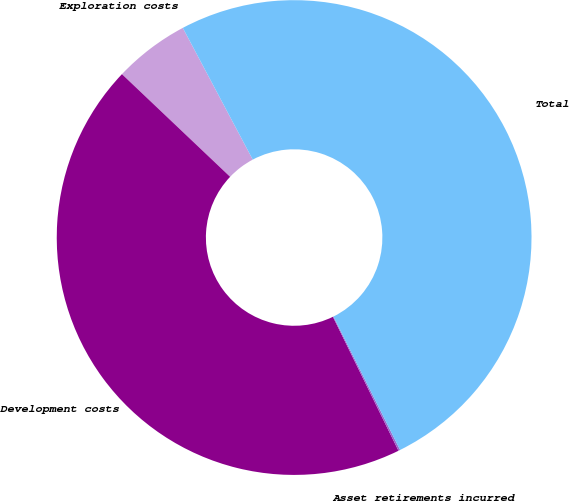<chart> <loc_0><loc_0><loc_500><loc_500><pie_chart><fcel>Exploration costs<fcel>Development costs<fcel>Asset retirements incurred<fcel>Total<nl><fcel>5.15%<fcel>44.33%<fcel>0.12%<fcel>50.41%<nl></chart> 